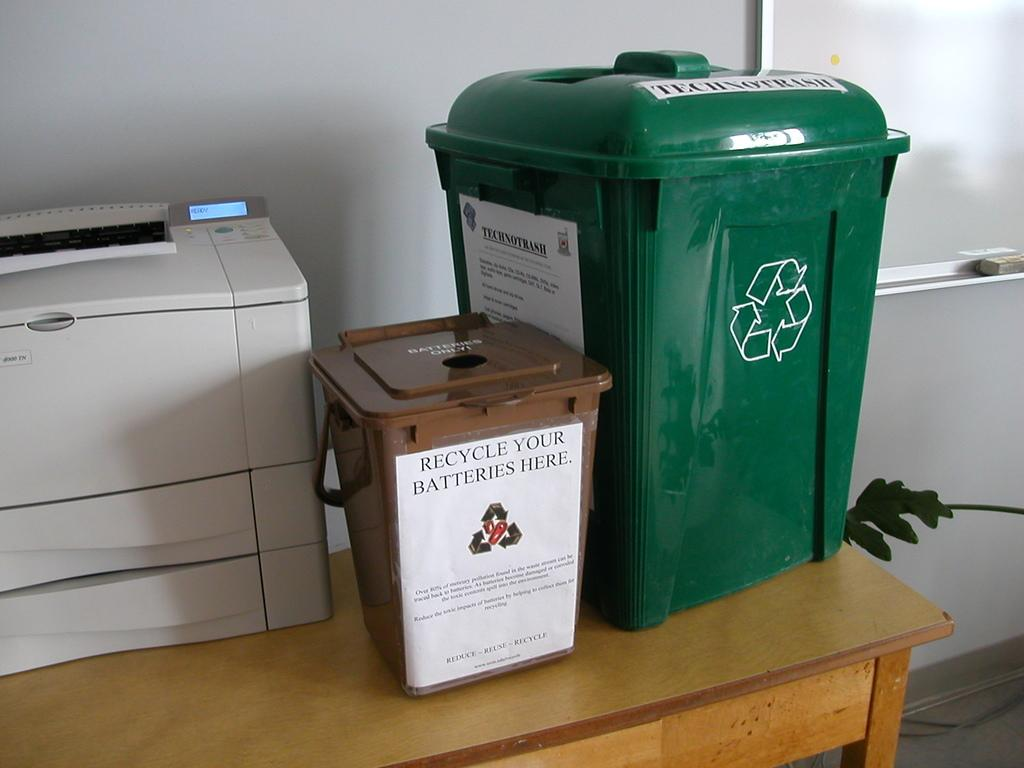<image>
Render a clear and concise summary of the photo. A brown trash can has a sign that reads "recycle your batteries here" 